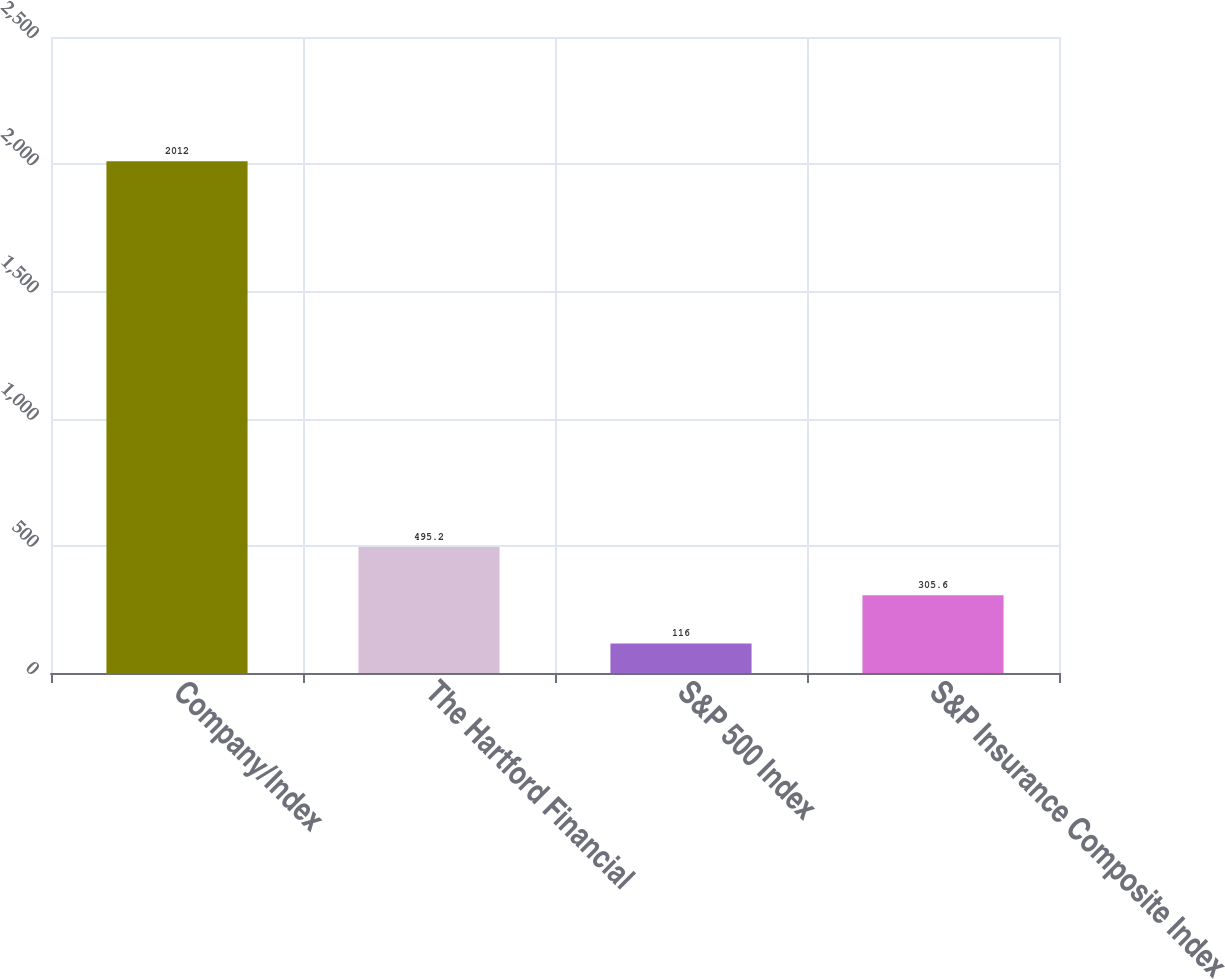Convert chart. <chart><loc_0><loc_0><loc_500><loc_500><bar_chart><fcel>Company/Index<fcel>The Hartford Financial<fcel>S&P 500 Index<fcel>S&P Insurance Composite Index<nl><fcel>2012<fcel>495.2<fcel>116<fcel>305.6<nl></chart> 